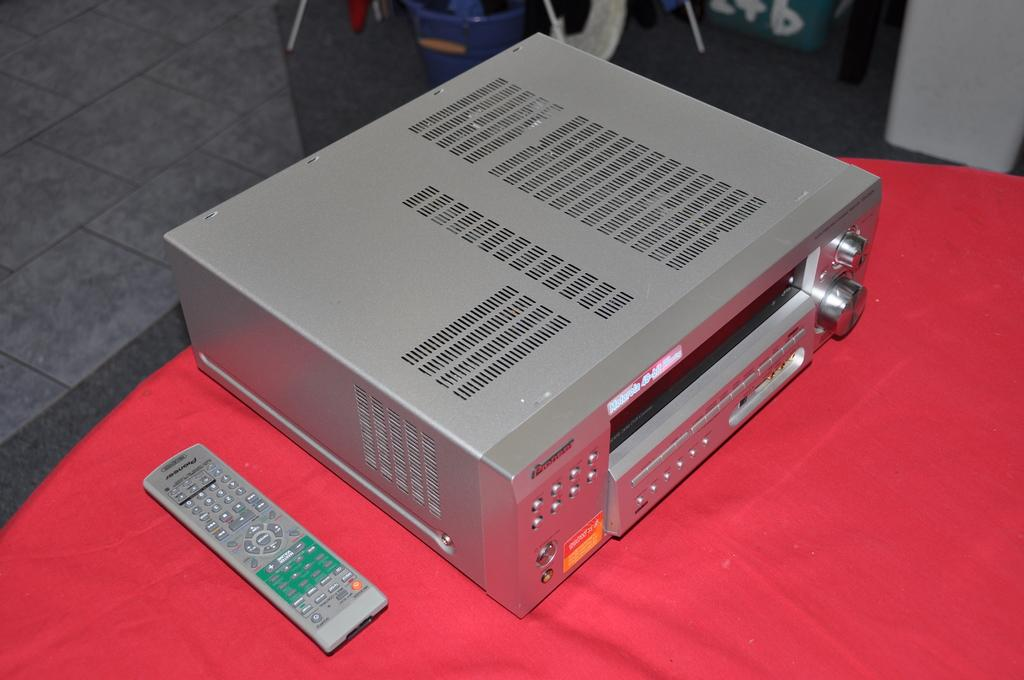<image>
Summarize the visual content of the image. A silver box which has the word Panasonic on the back of it. 